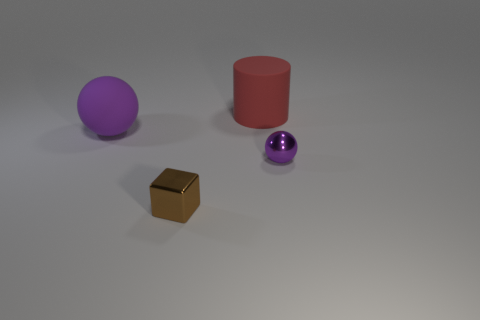What is the material of the small ball that is the same color as the big ball?
Ensure brevity in your answer.  Metal. Are there an equal number of large red cylinders that are in front of the red cylinder and tiny balls?
Keep it short and to the point. No. Are there any big rubber objects behind the large purple ball?
Offer a very short reply. Yes. There is a tiny purple metal thing; is its shape the same as the object in front of the tiny sphere?
Keep it short and to the point. No. There is a thing that is made of the same material as the tiny cube; what is its color?
Give a very brief answer. Purple. What is the color of the matte cylinder?
Provide a short and direct response. Red. Are the red object and the purple object that is on the left side of the small purple metallic thing made of the same material?
Give a very brief answer. Yes. How many things are both behind the brown shiny thing and in front of the red cylinder?
Keep it short and to the point. 2. What shape is the brown thing that is the same size as the purple metal ball?
Your answer should be very brief. Cube. There is a rubber object on the right side of the ball that is on the left side of the big cylinder; is there a purple rubber object in front of it?
Your answer should be very brief. Yes. 